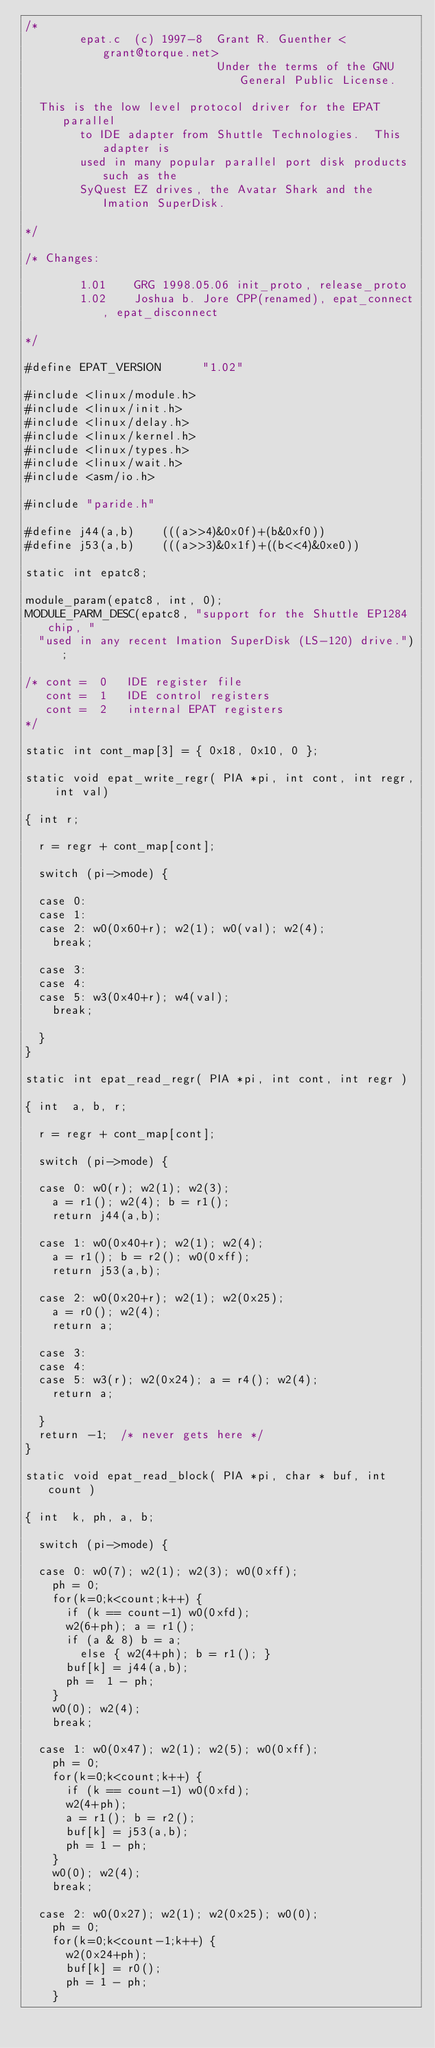<code> <loc_0><loc_0><loc_500><loc_500><_C_>/* 
        epat.c  (c) 1997-8  Grant R. Guenther <grant@torque.net>
                            Under the terms of the GNU General Public License.

	This is the low level protocol driver for the EPAT parallel
        to IDE adapter from Shuttle Technologies.  This adapter is
        used in many popular parallel port disk products such as the
        SyQuest EZ drives, the Avatar Shark and the Imation SuperDisk.
	
*/

/* Changes:

        1.01    GRG 1998.05.06 init_proto, release_proto
        1.02    Joshua b. Jore CPP(renamed), epat_connect, epat_disconnect

*/

#define EPAT_VERSION      "1.02"

#include <linux/module.h>
#include <linux/init.h>
#include <linux/delay.h>
#include <linux/kernel.h>
#include <linux/types.h>
#include <linux/wait.h>
#include <asm/io.h>

#include "paride.h"

#define j44(a,b)		(((a>>4)&0x0f)+(b&0xf0))
#define j53(a,b)		(((a>>3)&0x1f)+((b<<4)&0xe0))

static int epatc8;

module_param(epatc8, int, 0);
MODULE_PARM_DESC(epatc8, "support for the Shuttle EP1284 chip, "
	"used in any recent Imation SuperDisk (LS-120) drive.");

/* cont =  0   IDE register file
   cont =  1   IDE control registers
   cont =  2   internal EPAT registers
*/

static int cont_map[3] = { 0x18, 0x10, 0 };

static void epat_write_regr( PIA *pi, int cont, int regr, int val)

{	int r;

	r = regr + cont_map[cont];

	switch (pi->mode) {

	case 0:
	case 1:
	case 2:	w0(0x60+r); w2(1); w0(val); w2(4);
		break;

	case 3:
	case 4:
	case 5: w3(0x40+r); w4(val);
		break;

	}
}

static int epat_read_regr( PIA *pi, int cont, int regr )

{	int  a, b, r;

	r = regr + cont_map[cont];

	switch (pi->mode) {

	case 0:	w0(r); w2(1); w2(3); 
		a = r1(); w2(4); b = r1();
		return j44(a,b);

	case 1: w0(0x40+r); w2(1); w2(4);
		a = r1(); b = r2(); w0(0xff);
		return j53(a,b);

	case 2: w0(0x20+r); w2(1); w2(0x25);
		a = r0(); w2(4);
		return a;

	case 3:
	case 4:
	case 5: w3(r); w2(0x24); a = r4(); w2(4);
		return a;

	}
	return -1;	/* never gets here */
}

static void epat_read_block( PIA *pi, char * buf, int count )

{	int  k, ph, a, b;

	switch (pi->mode) {

	case 0:	w0(7); w2(1); w2(3); w0(0xff);
		ph = 0;
		for(k=0;k<count;k++) {
			if (k == count-1) w0(0xfd);
			w2(6+ph); a = r1();
			if (a & 8) b = a; 
			  else { w2(4+ph); b = r1(); }
			buf[k] = j44(a,b);
			ph =  1 - ph;
		}
		w0(0); w2(4);
		break;

	case 1: w0(0x47); w2(1); w2(5); w0(0xff);
		ph = 0;
		for(k=0;k<count;k++) {
			if (k == count-1) w0(0xfd); 
			w2(4+ph);
			a = r1(); b = r2();
			buf[k] = j53(a,b);
			ph = 1 - ph;
		}
		w0(0); w2(4);
		break;

	case 2: w0(0x27); w2(1); w2(0x25); w0(0);
		ph = 0;
		for(k=0;k<count-1;k++) {
			w2(0x24+ph);
			buf[k] = r0();
			ph = 1 - ph;
		}</code> 